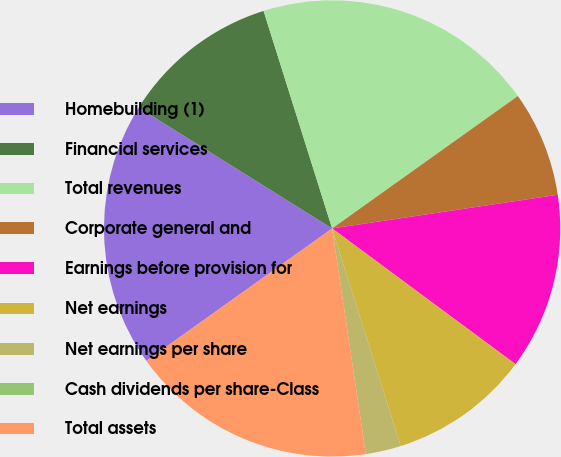<chart> <loc_0><loc_0><loc_500><loc_500><pie_chart><fcel>Homebuilding (1)<fcel>Financial services<fcel>Total revenues<fcel>Corporate general and<fcel>Earnings before provision for<fcel>Net earnings<fcel>Net earnings per share<fcel>Cash dividends per share-Class<fcel>Total assets<nl><fcel>18.75%<fcel>11.25%<fcel>20.0%<fcel>7.5%<fcel>12.5%<fcel>10.0%<fcel>2.5%<fcel>0.0%<fcel>17.5%<nl></chart> 